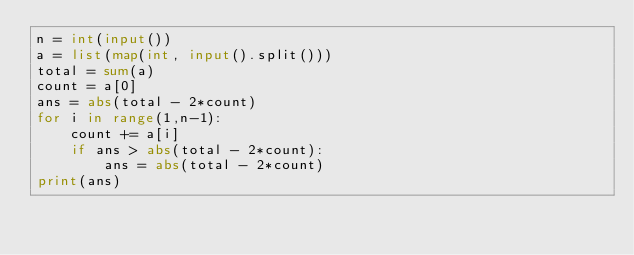<code> <loc_0><loc_0><loc_500><loc_500><_Python_>n = int(input())
a = list(map(int, input().split()))
total = sum(a)
count = a[0]
ans = abs(total - 2*count)
for i in range(1,n-1):
    count += a[i]
    if ans > abs(total - 2*count):
        ans = abs(total - 2*count)
print(ans)</code> 